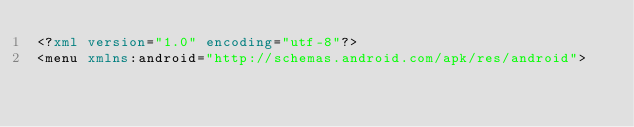Convert code to text. <code><loc_0><loc_0><loc_500><loc_500><_XML_><?xml version="1.0" encoding="utf-8"?>
<menu xmlns:android="http://schemas.android.com/apk/res/android">
</code> 